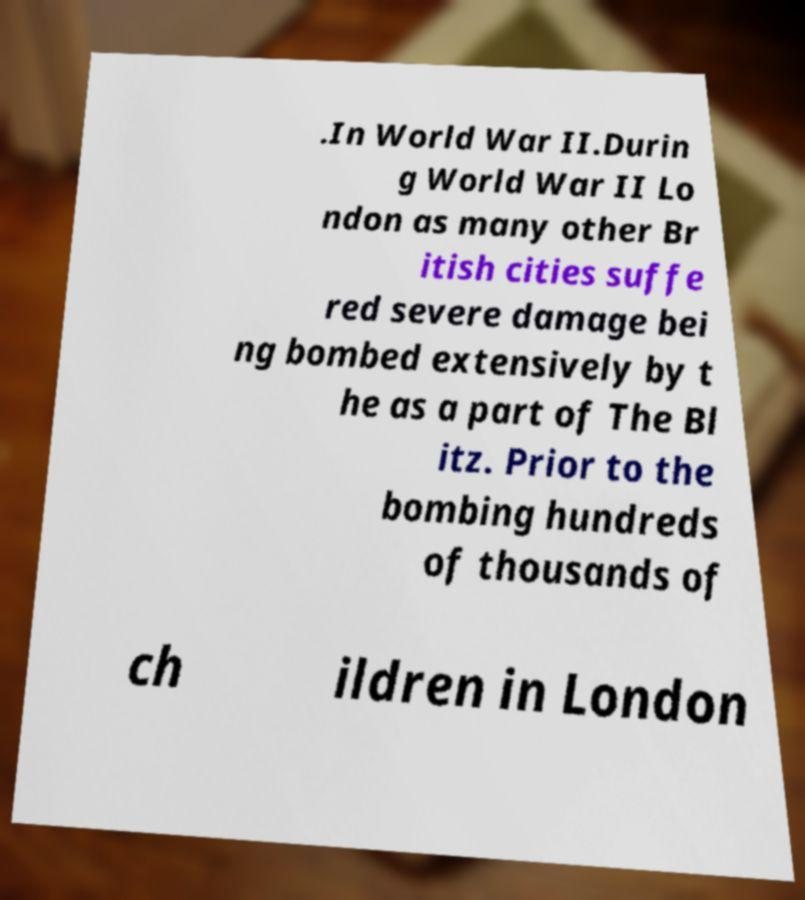For documentation purposes, I need the text within this image transcribed. Could you provide that? .In World War II.Durin g World War II Lo ndon as many other Br itish cities suffe red severe damage bei ng bombed extensively by t he as a part of The Bl itz. Prior to the bombing hundreds of thousands of ch ildren in London 